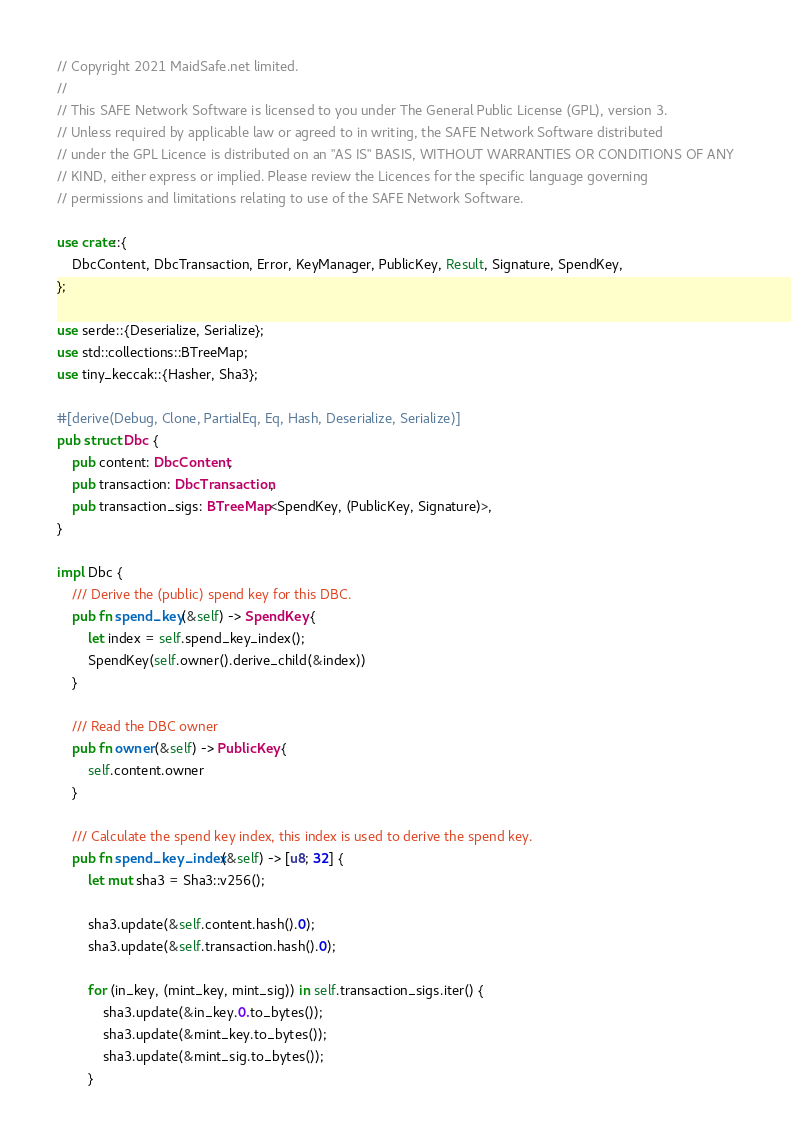<code> <loc_0><loc_0><loc_500><loc_500><_Rust_>// Copyright 2021 MaidSafe.net limited.
//
// This SAFE Network Software is licensed to you under The General Public License (GPL), version 3.
// Unless required by applicable law or agreed to in writing, the SAFE Network Software distributed
// under the GPL Licence is distributed on an "AS IS" BASIS, WITHOUT WARRANTIES OR CONDITIONS OF ANY
// KIND, either express or implied. Please review the Licences for the specific language governing
// permissions and limitations relating to use of the SAFE Network Software.

use crate::{
    DbcContent, DbcTransaction, Error, KeyManager, PublicKey, Result, Signature, SpendKey,
};

use serde::{Deserialize, Serialize};
use std::collections::BTreeMap;
use tiny_keccak::{Hasher, Sha3};

#[derive(Debug, Clone, PartialEq, Eq, Hash, Deserialize, Serialize)]
pub struct Dbc {
    pub content: DbcContent,
    pub transaction: DbcTransaction,
    pub transaction_sigs: BTreeMap<SpendKey, (PublicKey, Signature)>,
}

impl Dbc {
    /// Derive the (public) spend key for this DBC.
    pub fn spend_key(&self) -> SpendKey {
        let index = self.spend_key_index();
        SpendKey(self.owner().derive_child(&index))
    }

    /// Read the DBC owner
    pub fn owner(&self) -> PublicKey {
        self.content.owner
    }

    /// Calculate the spend key index, this index is used to derive the spend key.
    pub fn spend_key_index(&self) -> [u8; 32] {
        let mut sha3 = Sha3::v256();

        sha3.update(&self.content.hash().0);
        sha3.update(&self.transaction.hash().0);

        for (in_key, (mint_key, mint_sig)) in self.transaction_sigs.iter() {
            sha3.update(&in_key.0.to_bytes());
            sha3.update(&mint_key.to_bytes());
            sha3.update(&mint_sig.to_bytes());
        }
</code> 